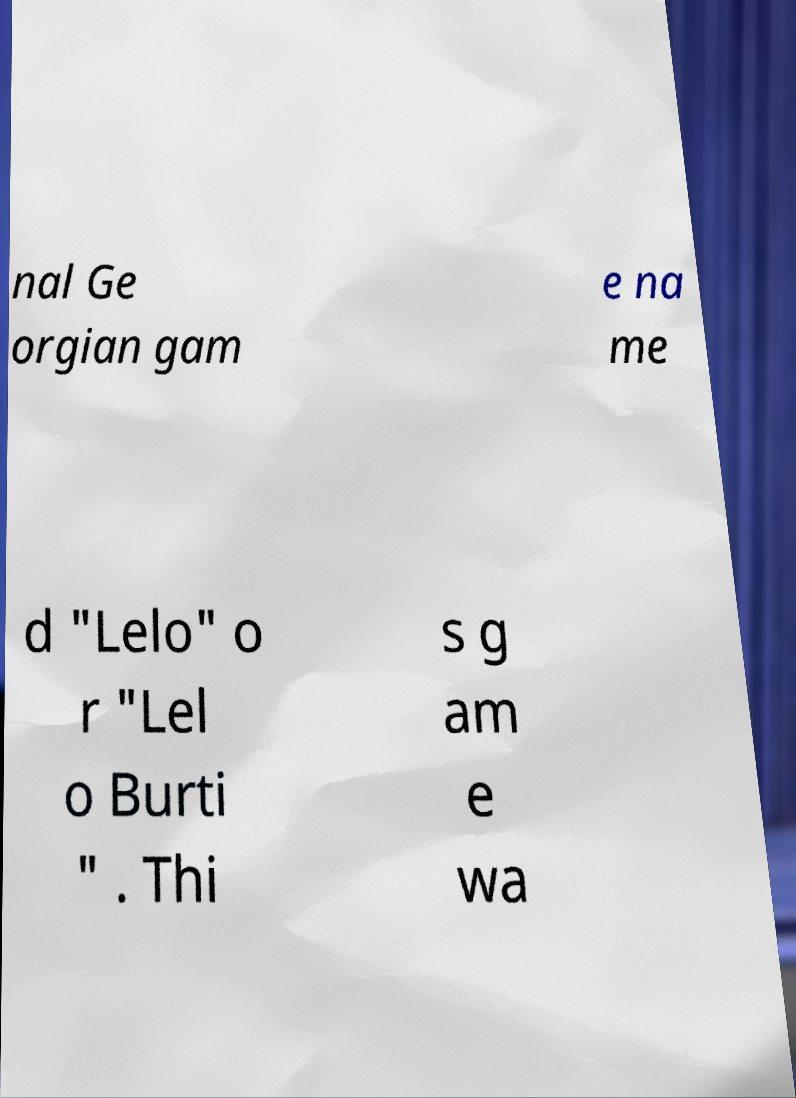Can you accurately transcribe the text from the provided image for me? nal Ge orgian gam e na me d "Lelo" o r "Lel o Burti " . Thi s g am e wa 